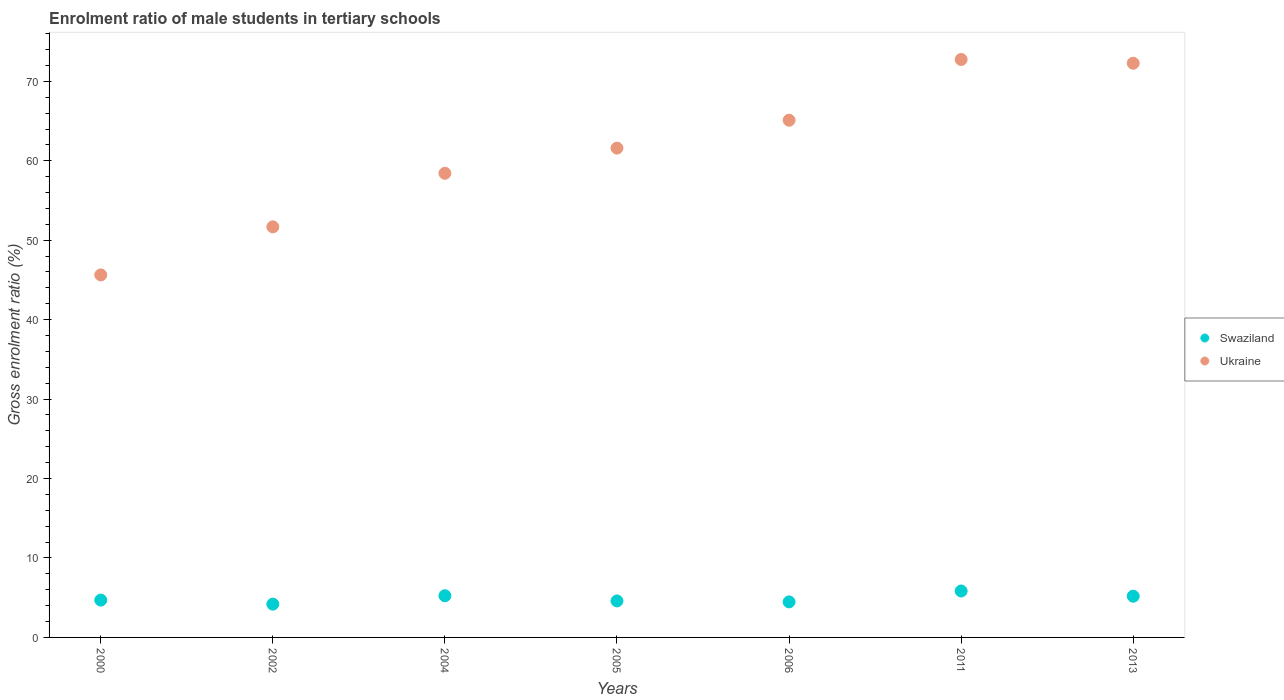Is the number of dotlines equal to the number of legend labels?
Ensure brevity in your answer.  Yes. What is the enrolment ratio of male students in tertiary schools in Swaziland in 2005?
Offer a very short reply. 4.59. Across all years, what is the maximum enrolment ratio of male students in tertiary schools in Swaziland?
Offer a terse response. 5.84. Across all years, what is the minimum enrolment ratio of male students in tertiary schools in Swaziland?
Your answer should be very brief. 4.19. In which year was the enrolment ratio of male students in tertiary schools in Ukraine minimum?
Offer a very short reply. 2000. What is the total enrolment ratio of male students in tertiary schools in Ukraine in the graph?
Offer a very short reply. 427.47. What is the difference between the enrolment ratio of male students in tertiary schools in Ukraine in 2002 and that in 2006?
Your answer should be very brief. -13.42. What is the difference between the enrolment ratio of male students in tertiary schools in Swaziland in 2011 and the enrolment ratio of male students in tertiary schools in Ukraine in 2000?
Provide a succinct answer. -39.79. What is the average enrolment ratio of male students in tertiary schools in Swaziland per year?
Ensure brevity in your answer.  4.89. In the year 2005, what is the difference between the enrolment ratio of male students in tertiary schools in Swaziland and enrolment ratio of male students in tertiary schools in Ukraine?
Your response must be concise. -57. What is the ratio of the enrolment ratio of male students in tertiary schools in Swaziland in 2006 to that in 2013?
Your answer should be compact. 0.86. Is the difference between the enrolment ratio of male students in tertiary schools in Swaziland in 2000 and 2004 greater than the difference between the enrolment ratio of male students in tertiary schools in Ukraine in 2000 and 2004?
Your answer should be compact. Yes. What is the difference between the highest and the second highest enrolment ratio of male students in tertiary schools in Ukraine?
Give a very brief answer. 0.47. What is the difference between the highest and the lowest enrolment ratio of male students in tertiary schools in Ukraine?
Keep it short and to the point. 27.12. Does the enrolment ratio of male students in tertiary schools in Ukraine monotonically increase over the years?
Provide a short and direct response. No. Is the enrolment ratio of male students in tertiary schools in Swaziland strictly greater than the enrolment ratio of male students in tertiary schools in Ukraine over the years?
Your answer should be compact. No. How many dotlines are there?
Provide a short and direct response. 2. Are the values on the major ticks of Y-axis written in scientific E-notation?
Provide a succinct answer. No. How many legend labels are there?
Your answer should be compact. 2. How are the legend labels stacked?
Provide a short and direct response. Vertical. What is the title of the graph?
Your response must be concise. Enrolment ratio of male students in tertiary schools. Does "High income: nonOECD" appear as one of the legend labels in the graph?
Ensure brevity in your answer.  No. What is the label or title of the Y-axis?
Your response must be concise. Gross enrolment ratio (%). What is the Gross enrolment ratio (%) in Swaziland in 2000?
Your answer should be very brief. 4.7. What is the Gross enrolment ratio (%) of Ukraine in 2000?
Ensure brevity in your answer.  45.63. What is the Gross enrolment ratio (%) in Swaziland in 2002?
Offer a very short reply. 4.19. What is the Gross enrolment ratio (%) of Ukraine in 2002?
Your answer should be compact. 51.68. What is the Gross enrolment ratio (%) in Swaziland in 2004?
Give a very brief answer. 5.25. What is the Gross enrolment ratio (%) of Ukraine in 2004?
Ensure brevity in your answer.  58.43. What is the Gross enrolment ratio (%) in Swaziland in 2005?
Give a very brief answer. 4.59. What is the Gross enrolment ratio (%) of Ukraine in 2005?
Offer a terse response. 61.6. What is the Gross enrolment ratio (%) in Swaziland in 2006?
Make the answer very short. 4.47. What is the Gross enrolment ratio (%) in Ukraine in 2006?
Provide a short and direct response. 65.1. What is the Gross enrolment ratio (%) of Swaziland in 2011?
Keep it short and to the point. 5.84. What is the Gross enrolment ratio (%) of Ukraine in 2011?
Ensure brevity in your answer.  72.75. What is the Gross enrolment ratio (%) of Swaziland in 2013?
Make the answer very short. 5.19. What is the Gross enrolment ratio (%) in Ukraine in 2013?
Offer a terse response. 72.28. Across all years, what is the maximum Gross enrolment ratio (%) of Swaziland?
Your response must be concise. 5.84. Across all years, what is the maximum Gross enrolment ratio (%) of Ukraine?
Give a very brief answer. 72.75. Across all years, what is the minimum Gross enrolment ratio (%) in Swaziland?
Keep it short and to the point. 4.19. Across all years, what is the minimum Gross enrolment ratio (%) in Ukraine?
Your response must be concise. 45.63. What is the total Gross enrolment ratio (%) in Swaziland in the graph?
Your answer should be compact. 34.24. What is the total Gross enrolment ratio (%) of Ukraine in the graph?
Your answer should be very brief. 427.47. What is the difference between the Gross enrolment ratio (%) of Swaziland in 2000 and that in 2002?
Your answer should be very brief. 0.51. What is the difference between the Gross enrolment ratio (%) in Ukraine in 2000 and that in 2002?
Give a very brief answer. -6.05. What is the difference between the Gross enrolment ratio (%) of Swaziland in 2000 and that in 2004?
Make the answer very short. -0.55. What is the difference between the Gross enrolment ratio (%) in Ukraine in 2000 and that in 2004?
Provide a short and direct response. -12.8. What is the difference between the Gross enrolment ratio (%) of Swaziland in 2000 and that in 2005?
Ensure brevity in your answer.  0.11. What is the difference between the Gross enrolment ratio (%) of Ukraine in 2000 and that in 2005?
Offer a very short reply. -15.96. What is the difference between the Gross enrolment ratio (%) in Swaziland in 2000 and that in 2006?
Offer a terse response. 0.23. What is the difference between the Gross enrolment ratio (%) in Ukraine in 2000 and that in 2006?
Your answer should be very brief. -19.47. What is the difference between the Gross enrolment ratio (%) of Swaziland in 2000 and that in 2011?
Make the answer very short. -1.14. What is the difference between the Gross enrolment ratio (%) of Ukraine in 2000 and that in 2011?
Keep it short and to the point. -27.12. What is the difference between the Gross enrolment ratio (%) of Swaziland in 2000 and that in 2013?
Your answer should be compact. -0.49. What is the difference between the Gross enrolment ratio (%) of Ukraine in 2000 and that in 2013?
Provide a short and direct response. -26.65. What is the difference between the Gross enrolment ratio (%) of Swaziland in 2002 and that in 2004?
Provide a short and direct response. -1.06. What is the difference between the Gross enrolment ratio (%) of Ukraine in 2002 and that in 2004?
Your response must be concise. -6.74. What is the difference between the Gross enrolment ratio (%) of Swaziland in 2002 and that in 2005?
Make the answer very short. -0.4. What is the difference between the Gross enrolment ratio (%) of Ukraine in 2002 and that in 2005?
Your response must be concise. -9.91. What is the difference between the Gross enrolment ratio (%) of Swaziland in 2002 and that in 2006?
Keep it short and to the point. -0.28. What is the difference between the Gross enrolment ratio (%) of Ukraine in 2002 and that in 2006?
Give a very brief answer. -13.42. What is the difference between the Gross enrolment ratio (%) in Swaziland in 2002 and that in 2011?
Your answer should be very brief. -1.65. What is the difference between the Gross enrolment ratio (%) in Ukraine in 2002 and that in 2011?
Your answer should be very brief. -21.07. What is the difference between the Gross enrolment ratio (%) of Swaziland in 2002 and that in 2013?
Provide a short and direct response. -1. What is the difference between the Gross enrolment ratio (%) of Ukraine in 2002 and that in 2013?
Your answer should be compact. -20.59. What is the difference between the Gross enrolment ratio (%) of Swaziland in 2004 and that in 2005?
Your response must be concise. 0.65. What is the difference between the Gross enrolment ratio (%) of Ukraine in 2004 and that in 2005?
Keep it short and to the point. -3.17. What is the difference between the Gross enrolment ratio (%) of Swaziland in 2004 and that in 2006?
Give a very brief answer. 0.77. What is the difference between the Gross enrolment ratio (%) in Ukraine in 2004 and that in 2006?
Your answer should be very brief. -6.68. What is the difference between the Gross enrolment ratio (%) of Swaziland in 2004 and that in 2011?
Your answer should be compact. -0.6. What is the difference between the Gross enrolment ratio (%) of Ukraine in 2004 and that in 2011?
Your answer should be compact. -14.32. What is the difference between the Gross enrolment ratio (%) in Swaziland in 2004 and that in 2013?
Your response must be concise. 0.06. What is the difference between the Gross enrolment ratio (%) in Ukraine in 2004 and that in 2013?
Your answer should be very brief. -13.85. What is the difference between the Gross enrolment ratio (%) of Swaziland in 2005 and that in 2006?
Give a very brief answer. 0.12. What is the difference between the Gross enrolment ratio (%) of Ukraine in 2005 and that in 2006?
Give a very brief answer. -3.51. What is the difference between the Gross enrolment ratio (%) of Swaziland in 2005 and that in 2011?
Keep it short and to the point. -1.25. What is the difference between the Gross enrolment ratio (%) in Ukraine in 2005 and that in 2011?
Your response must be concise. -11.16. What is the difference between the Gross enrolment ratio (%) in Swaziland in 2005 and that in 2013?
Keep it short and to the point. -0.6. What is the difference between the Gross enrolment ratio (%) of Ukraine in 2005 and that in 2013?
Give a very brief answer. -10.68. What is the difference between the Gross enrolment ratio (%) in Swaziland in 2006 and that in 2011?
Your answer should be compact. -1.37. What is the difference between the Gross enrolment ratio (%) of Ukraine in 2006 and that in 2011?
Ensure brevity in your answer.  -7.65. What is the difference between the Gross enrolment ratio (%) of Swaziland in 2006 and that in 2013?
Give a very brief answer. -0.72. What is the difference between the Gross enrolment ratio (%) of Ukraine in 2006 and that in 2013?
Offer a very short reply. -7.17. What is the difference between the Gross enrolment ratio (%) of Swaziland in 2011 and that in 2013?
Offer a very short reply. 0.65. What is the difference between the Gross enrolment ratio (%) of Ukraine in 2011 and that in 2013?
Keep it short and to the point. 0.47. What is the difference between the Gross enrolment ratio (%) in Swaziland in 2000 and the Gross enrolment ratio (%) in Ukraine in 2002?
Offer a very short reply. -46.98. What is the difference between the Gross enrolment ratio (%) of Swaziland in 2000 and the Gross enrolment ratio (%) of Ukraine in 2004?
Make the answer very short. -53.73. What is the difference between the Gross enrolment ratio (%) of Swaziland in 2000 and the Gross enrolment ratio (%) of Ukraine in 2005?
Your response must be concise. -56.9. What is the difference between the Gross enrolment ratio (%) in Swaziland in 2000 and the Gross enrolment ratio (%) in Ukraine in 2006?
Offer a terse response. -60.4. What is the difference between the Gross enrolment ratio (%) in Swaziland in 2000 and the Gross enrolment ratio (%) in Ukraine in 2011?
Offer a terse response. -68.05. What is the difference between the Gross enrolment ratio (%) of Swaziland in 2000 and the Gross enrolment ratio (%) of Ukraine in 2013?
Offer a very short reply. -67.58. What is the difference between the Gross enrolment ratio (%) in Swaziland in 2002 and the Gross enrolment ratio (%) in Ukraine in 2004?
Provide a short and direct response. -54.23. What is the difference between the Gross enrolment ratio (%) of Swaziland in 2002 and the Gross enrolment ratio (%) of Ukraine in 2005?
Your response must be concise. -57.4. What is the difference between the Gross enrolment ratio (%) of Swaziland in 2002 and the Gross enrolment ratio (%) of Ukraine in 2006?
Provide a succinct answer. -60.91. What is the difference between the Gross enrolment ratio (%) in Swaziland in 2002 and the Gross enrolment ratio (%) in Ukraine in 2011?
Keep it short and to the point. -68.56. What is the difference between the Gross enrolment ratio (%) of Swaziland in 2002 and the Gross enrolment ratio (%) of Ukraine in 2013?
Your answer should be very brief. -68.08. What is the difference between the Gross enrolment ratio (%) in Swaziland in 2004 and the Gross enrolment ratio (%) in Ukraine in 2005?
Give a very brief answer. -56.35. What is the difference between the Gross enrolment ratio (%) in Swaziland in 2004 and the Gross enrolment ratio (%) in Ukraine in 2006?
Your response must be concise. -59.86. What is the difference between the Gross enrolment ratio (%) in Swaziland in 2004 and the Gross enrolment ratio (%) in Ukraine in 2011?
Your response must be concise. -67.5. What is the difference between the Gross enrolment ratio (%) in Swaziland in 2004 and the Gross enrolment ratio (%) in Ukraine in 2013?
Your response must be concise. -67.03. What is the difference between the Gross enrolment ratio (%) in Swaziland in 2005 and the Gross enrolment ratio (%) in Ukraine in 2006?
Make the answer very short. -60.51. What is the difference between the Gross enrolment ratio (%) of Swaziland in 2005 and the Gross enrolment ratio (%) of Ukraine in 2011?
Offer a terse response. -68.16. What is the difference between the Gross enrolment ratio (%) of Swaziland in 2005 and the Gross enrolment ratio (%) of Ukraine in 2013?
Provide a succinct answer. -67.68. What is the difference between the Gross enrolment ratio (%) in Swaziland in 2006 and the Gross enrolment ratio (%) in Ukraine in 2011?
Ensure brevity in your answer.  -68.28. What is the difference between the Gross enrolment ratio (%) of Swaziland in 2006 and the Gross enrolment ratio (%) of Ukraine in 2013?
Your response must be concise. -67.8. What is the difference between the Gross enrolment ratio (%) of Swaziland in 2011 and the Gross enrolment ratio (%) of Ukraine in 2013?
Offer a terse response. -66.43. What is the average Gross enrolment ratio (%) in Swaziland per year?
Offer a very short reply. 4.89. What is the average Gross enrolment ratio (%) in Ukraine per year?
Ensure brevity in your answer.  61.07. In the year 2000, what is the difference between the Gross enrolment ratio (%) of Swaziland and Gross enrolment ratio (%) of Ukraine?
Make the answer very short. -40.93. In the year 2002, what is the difference between the Gross enrolment ratio (%) of Swaziland and Gross enrolment ratio (%) of Ukraine?
Make the answer very short. -47.49. In the year 2004, what is the difference between the Gross enrolment ratio (%) in Swaziland and Gross enrolment ratio (%) in Ukraine?
Offer a very short reply. -53.18. In the year 2005, what is the difference between the Gross enrolment ratio (%) of Swaziland and Gross enrolment ratio (%) of Ukraine?
Offer a very short reply. -57. In the year 2006, what is the difference between the Gross enrolment ratio (%) in Swaziland and Gross enrolment ratio (%) in Ukraine?
Your response must be concise. -60.63. In the year 2011, what is the difference between the Gross enrolment ratio (%) in Swaziland and Gross enrolment ratio (%) in Ukraine?
Ensure brevity in your answer.  -66.91. In the year 2013, what is the difference between the Gross enrolment ratio (%) of Swaziland and Gross enrolment ratio (%) of Ukraine?
Your response must be concise. -67.09. What is the ratio of the Gross enrolment ratio (%) in Swaziland in 2000 to that in 2002?
Provide a succinct answer. 1.12. What is the ratio of the Gross enrolment ratio (%) in Ukraine in 2000 to that in 2002?
Make the answer very short. 0.88. What is the ratio of the Gross enrolment ratio (%) of Swaziland in 2000 to that in 2004?
Your answer should be compact. 0.9. What is the ratio of the Gross enrolment ratio (%) in Ukraine in 2000 to that in 2004?
Offer a very short reply. 0.78. What is the ratio of the Gross enrolment ratio (%) of Swaziland in 2000 to that in 2005?
Keep it short and to the point. 1.02. What is the ratio of the Gross enrolment ratio (%) in Ukraine in 2000 to that in 2005?
Provide a short and direct response. 0.74. What is the ratio of the Gross enrolment ratio (%) in Swaziland in 2000 to that in 2006?
Provide a short and direct response. 1.05. What is the ratio of the Gross enrolment ratio (%) in Ukraine in 2000 to that in 2006?
Offer a terse response. 0.7. What is the ratio of the Gross enrolment ratio (%) of Swaziland in 2000 to that in 2011?
Provide a succinct answer. 0.8. What is the ratio of the Gross enrolment ratio (%) of Ukraine in 2000 to that in 2011?
Your answer should be very brief. 0.63. What is the ratio of the Gross enrolment ratio (%) in Swaziland in 2000 to that in 2013?
Keep it short and to the point. 0.91. What is the ratio of the Gross enrolment ratio (%) in Ukraine in 2000 to that in 2013?
Give a very brief answer. 0.63. What is the ratio of the Gross enrolment ratio (%) in Swaziland in 2002 to that in 2004?
Provide a succinct answer. 0.8. What is the ratio of the Gross enrolment ratio (%) in Ukraine in 2002 to that in 2004?
Your answer should be very brief. 0.88. What is the ratio of the Gross enrolment ratio (%) in Swaziland in 2002 to that in 2005?
Provide a succinct answer. 0.91. What is the ratio of the Gross enrolment ratio (%) in Ukraine in 2002 to that in 2005?
Your answer should be compact. 0.84. What is the ratio of the Gross enrolment ratio (%) in Swaziland in 2002 to that in 2006?
Provide a short and direct response. 0.94. What is the ratio of the Gross enrolment ratio (%) in Ukraine in 2002 to that in 2006?
Keep it short and to the point. 0.79. What is the ratio of the Gross enrolment ratio (%) of Swaziland in 2002 to that in 2011?
Provide a short and direct response. 0.72. What is the ratio of the Gross enrolment ratio (%) of Ukraine in 2002 to that in 2011?
Ensure brevity in your answer.  0.71. What is the ratio of the Gross enrolment ratio (%) of Swaziland in 2002 to that in 2013?
Make the answer very short. 0.81. What is the ratio of the Gross enrolment ratio (%) of Ukraine in 2002 to that in 2013?
Offer a terse response. 0.72. What is the ratio of the Gross enrolment ratio (%) in Swaziland in 2004 to that in 2005?
Offer a terse response. 1.14. What is the ratio of the Gross enrolment ratio (%) in Ukraine in 2004 to that in 2005?
Provide a short and direct response. 0.95. What is the ratio of the Gross enrolment ratio (%) in Swaziland in 2004 to that in 2006?
Provide a short and direct response. 1.17. What is the ratio of the Gross enrolment ratio (%) of Ukraine in 2004 to that in 2006?
Offer a very short reply. 0.9. What is the ratio of the Gross enrolment ratio (%) of Swaziland in 2004 to that in 2011?
Your answer should be compact. 0.9. What is the ratio of the Gross enrolment ratio (%) of Ukraine in 2004 to that in 2011?
Keep it short and to the point. 0.8. What is the ratio of the Gross enrolment ratio (%) in Ukraine in 2004 to that in 2013?
Make the answer very short. 0.81. What is the ratio of the Gross enrolment ratio (%) in Swaziland in 2005 to that in 2006?
Provide a succinct answer. 1.03. What is the ratio of the Gross enrolment ratio (%) in Ukraine in 2005 to that in 2006?
Offer a very short reply. 0.95. What is the ratio of the Gross enrolment ratio (%) of Swaziland in 2005 to that in 2011?
Offer a terse response. 0.79. What is the ratio of the Gross enrolment ratio (%) of Ukraine in 2005 to that in 2011?
Your answer should be very brief. 0.85. What is the ratio of the Gross enrolment ratio (%) of Swaziland in 2005 to that in 2013?
Offer a terse response. 0.89. What is the ratio of the Gross enrolment ratio (%) in Ukraine in 2005 to that in 2013?
Provide a short and direct response. 0.85. What is the ratio of the Gross enrolment ratio (%) in Swaziland in 2006 to that in 2011?
Provide a short and direct response. 0.77. What is the ratio of the Gross enrolment ratio (%) in Ukraine in 2006 to that in 2011?
Your answer should be very brief. 0.89. What is the ratio of the Gross enrolment ratio (%) of Swaziland in 2006 to that in 2013?
Give a very brief answer. 0.86. What is the ratio of the Gross enrolment ratio (%) of Ukraine in 2006 to that in 2013?
Your answer should be very brief. 0.9. What is the ratio of the Gross enrolment ratio (%) in Swaziland in 2011 to that in 2013?
Keep it short and to the point. 1.13. What is the ratio of the Gross enrolment ratio (%) in Ukraine in 2011 to that in 2013?
Your response must be concise. 1.01. What is the difference between the highest and the second highest Gross enrolment ratio (%) in Swaziland?
Offer a terse response. 0.6. What is the difference between the highest and the second highest Gross enrolment ratio (%) of Ukraine?
Ensure brevity in your answer.  0.47. What is the difference between the highest and the lowest Gross enrolment ratio (%) of Swaziland?
Your response must be concise. 1.65. What is the difference between the highest and the lowest Gross enrolment ratio (%) of Ukraine?
Make the answer very short. 27.12. 